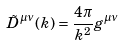Convert formula to latex. <formula><loc_0><loc_0><loc_500><loc_500>\tilde { D } ^ { \mu \nu } ( k ) = \frac { 4 \pi } { k ^ { 2 } } g ^ { \mu \nu }</formula> 